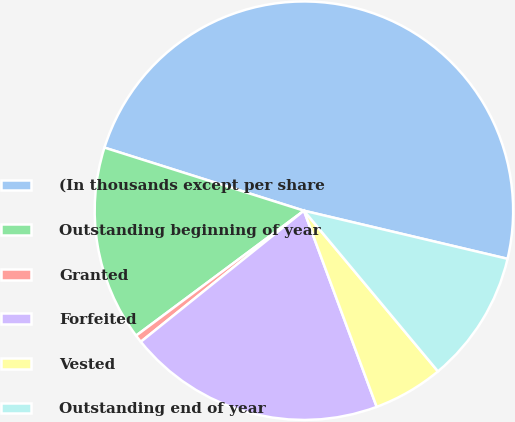<chart> <loc_0><loc_0><loc_500><loc_500><pie_chart><fcel>(In thousands except per share<fcel>Outstanding beginning of year<fcel>Granted<fcel>Forfeited<fcel>Vested<fcel>Outstanding end of year<nl><fcel>48.82%<fcel>15.06%<fcel>0.59%<fcel>19.88%<fcel>5.41%<fcel>10.24%<nl></chart> 